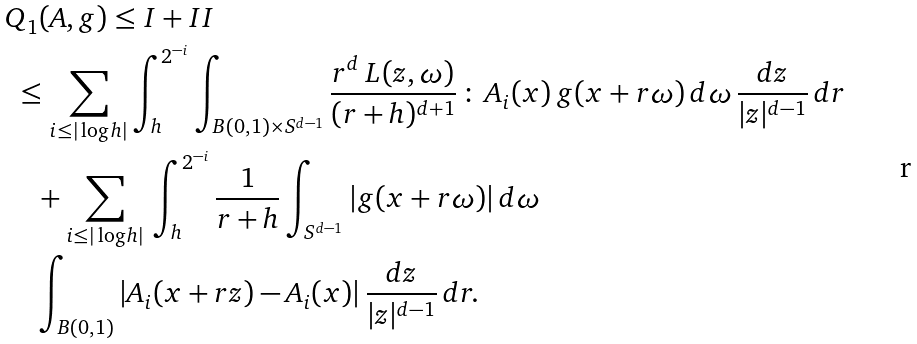<formula> <loc_0><loc_0><loc_500><loc_500>& Q _ { 1 } ( A , g ) \leq I + I I \\ & \ \leq \sum _ { i \leq | \log h | } \int _ { h } ^ { 2 ^ { - i } } \int _ { B ( 0 , 1 ) \times S ^ { d - 1 } } \frac { r ^ { d } \, L ( z , \omega ) } { ( r + h ) ^ { d + 1 } } \, \colon \, A _ { i } ( x ) \, g ( x + r \omega ) \, d \omega \, \frac { d z } { | z | ^ { d - 1 } } \, d r \\ & \quad + \sum _ { i \leq | \log h | } \, \int _ { h } ^ { 2 ^ { - i } } \frac { 1 } { r + h } \int _ { S ^ { d - 1 } } | g ( x + r \omega ) | \, d \omega \\ & \quad \int _ { B ( 0 , 1 ) } | A _ { i } ( x + r z ) - A _ { i } ( x ) | \, \frac { d z } { | z | ^ { d - 1 } } \, d r .</formula> 